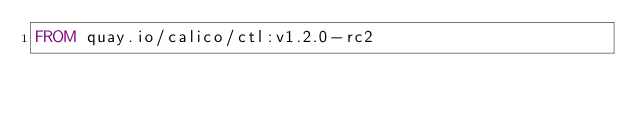Convert code to text. <code><loc_0><loc_0><loc_500><loc_500><_Dockerfile_>FROM quay.io/calico/ctl:v1.2.0-rc2
</code> 